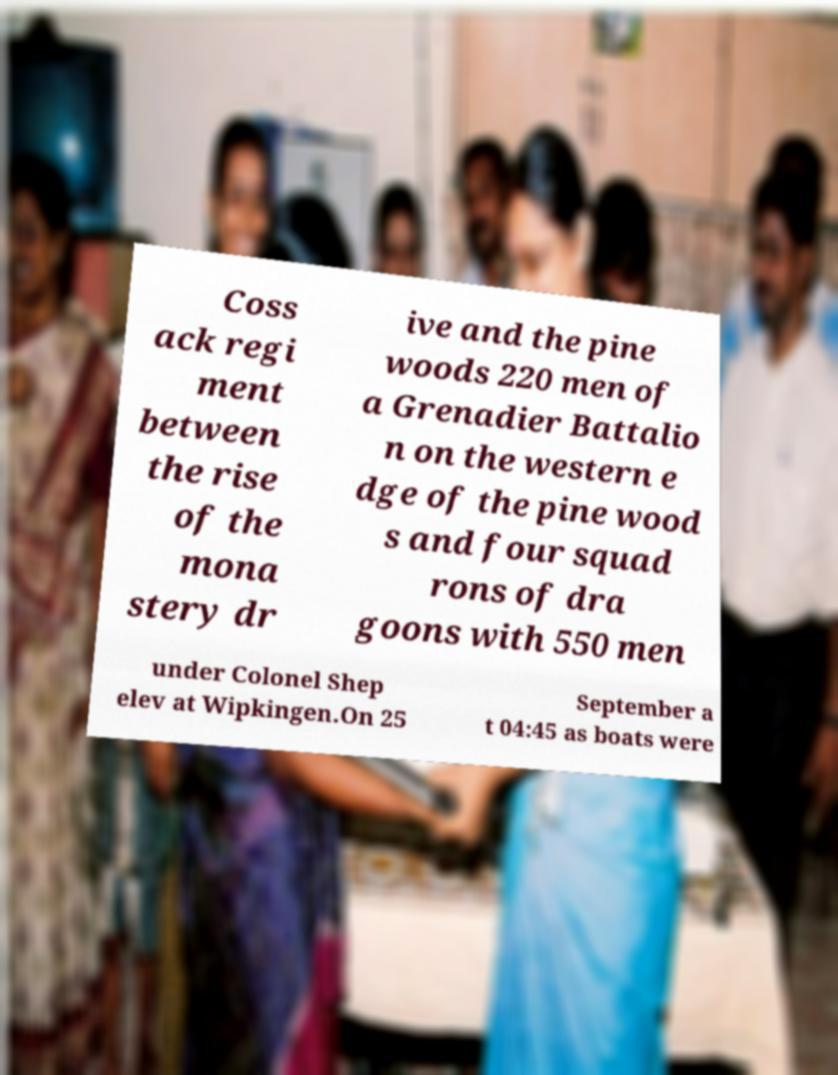Can you read and provide the text displayed in the image?This photo seems to have some interesting text. Can you extract and type it out for me? Coss ack regi ment between the rise of the mona stery dr ive and the pine woods 220 men of a Grenadier Battalio n on the western e dge of the pine wood s and four squad rons of dra goons with 550 men under Colonel Shep elev at Wipkingen.On 25 September a t 04:45 as boats were 